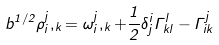<formula> <loc_0><loc_0><loc_500><loc_500>b ^ { 1 / 2 } \rho _ { i } ^ { j } , _ { k } = \omega _ { i } ^ { j } , _ { k } + \frac { 1 } { 2 } \delta _ { j } ^ { i } \Gamma _ { k l } ^ { l } - \Gamma _ { i k } ^ { j }</formula> 